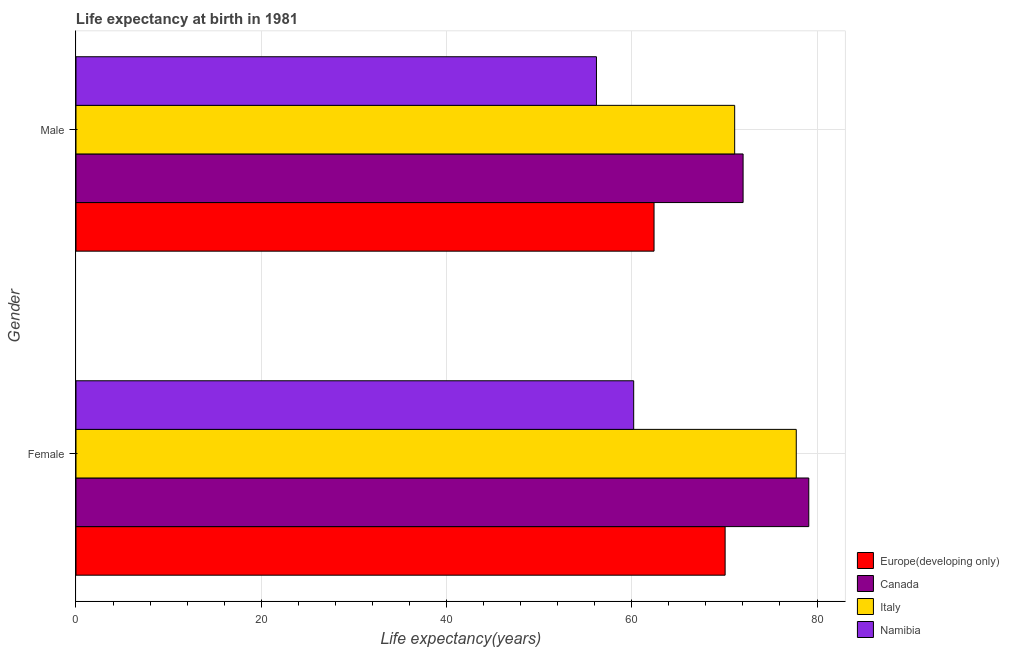How many different coloured bars are there?
Provide a short and direct response. 4. How many groups of bars are there?
Your response must be concise. 2. Are the number of bars per tick equal to the number of legend labels?
Offer a very short reply. Yes. Are the number of bars on each tick of the Y-axis equal?
Give a very brief answer. Yes. How many bars are there on the 2nd tick from the top?
Your answer should be very brief. 4. How many bars are there on the 1st tick from the bottom?
Your response must be concise. 4. What is the life expectancy(female) in Canada?
Your response must be concise. 79.11. Across all countries, what is the maximum life expectancy(female)?
Offer a very short reply. 79.11. Across all countries, what is the minimum life expectancy(male)?
Keep it short and to the point. 56.19. In which country was the life expectancy(female) minimum?
Your answer should be compact. Namibia. What is the total life expectancy(female) in the graph?
Give a very brief answer. 287.16. What is the difference between the life expectancy(female) in Namibia and that in Europe(developing only)?
Make the answer very short. -9.87. What is the difference between the life expectancy(female) in Canada and the life expectancy(male) in Europe(developing only)?
Offer a very short reply. 16.7. What is the average life expectancy(female) per country?
Make the answer very short. 71.79. What is the difference between the life expectancy(female) and life expectancy(male) in Italy?
Offer a very short reply. 6.65. In how many countries, is the life expectancy(male) greater than 12 years?
Give a very brief answer. 4. What is the ratio of the life expectancy(male) in Europe(developing only) to that in Namibia?
Provide a succinct answer. 1.11. In how many countries, is the life expectancy(male) greater than the average life expectancy(male) taken over all countries?
Your response must be concise. 2. What does the 3rd bar from the bottom in Female represents?
Your response must be concise. Italy. How many countries are there in the graph?
Make the answer very short. 4. Does the graph contain any zero values?
Offer a terse response. No. Does the graph contain grids?
Keep it short and to the point. Yes. Where does the legend appear in the graph?
Your answer should be compact. Bottom right. How many legend labels are there?
Ensure brevity in your answer.  4. How are the legend labels stacked?
Offer a terse response. Vertical. What is the title of the graph?
Offer a very short reply. Life expectancy at birth in 1981. Does "Luxembourg" appear as one of the legend labels in the graph?
Make the answer very short. No. What is the label or title of the X-axis?
Offer a terse response. Life expectancy(years). What is the Life expectancy(years) of Europe(developing only) in Female?
Offer a terse response. 70.08. What is the Life expectancy(years) in Canada in Female?
Make the answer very short. 79.11. What is the Life expectancy(years) of Italy in Female?
Give a very brief answer. 77.76. What is the Life expectancy(years) in Namibia in Female?
Provide a succinct answer. 60.21. What is the Life expectancy(years) of Europe(developing only) in Male?
Offer a terse response. 62.41. What is the Life expectancy(years) of Canada in Male?
Offer a very short reply. 72.02. What is the Life expectancy(years) in Italy in Male?
Offer a very short reply. 71.11. What is the Life expectancy(years) of Namibia in Male?
Keep it short and to the point. 56.19. Across all Gender, what is the maximum Life expectancy(years) in Europe(developing only)?
Provide a succinct answer. 70.08. Across all Gender, what is the maximum Life expectancy(years) of Canada?
Provide a succinct answer. 79.11. Across all Gender, what is the maximum Life expectancy(years) in Italy?
Provide a short and direct response. 77.76. Across all Gender, what is the maximum Life expectancy(years) in Namibia?
Give a very brief answer. 60.21. Across all Gender, what is the minimum Life expectancy(years) in Europe(developing only)?
Give a very brief answer. 62.41. Across all Gender, what is the minimum Life expectancy(years) of Canada?
Provide a succinct answer. 72.02. Across all Gender, what is the minimum Life expectancy(years) of Italy?
Offer a very short reply. 71.11. Across all Gender, what is the minimum Life expectancy(years) of Namibia?
Offer a very short reply. 56.19. What is the total Life expectancy(years) of Europe(developing only) in the graph?
Offer a terse response. 132.48. What is the total Life expectancy(years) in Canada in the graph?
Your answer should be very brief. 151.13. What is the total Life expectancy(years) of Italy in the graph?
Give a very brief answer. 148.87. What is the total Life expectancy(years) of Namibia in the graph?
Your response must be concise. 116.4. What is the difference between the Life expectancy(years) of Europe(developing only) in Female and that in Male?
Keep it short and to the point. 7.67. What is the difference between the Life expectancy(years) of Canada in Female and that in Male?
Your answer should be compact. 7.09. What is the difference between the Life expectancy(years) in Italy in Female and that in Male?
Provide a short and direct response. 6.65. What is the difference between the Life expectancy(years) in Namibia in Female and that in Male?
Ensure brevity in your answer.  4.02. What is the difference between the Life expectancy(years) in Europe(developing only) in Female and the Life expectancy(years) in Canada in Male?
Ensure brevity in your answer.  -1.94. What is the difference between the Life expectancy(years) of Europe(developing only) in Female and the Life expectancy(years) of Italy in Male?
Your answer should be very brief. -1.03. What is the difference between the Life expectancy(years) of Europe(developing only) in Female and the Life expectancy(years) of Namibia in Male?
Ensure brevity in your answer.  13.89. What is the difference between the Life expectancy(years) in Canada in Female and the Life expectancy(years) in Italy in Male?
Offer a very short reply. 8. What is the difference between the Life expectancy(years) in Canada in Female and the Life expectancy(years) in Namibia in Male?
Make the answer very short. 22.92. What is the difference between the Life expectancy(years) in Italy in Female and the Life expectancy(years) in Namibia in Male?
Ensure brevity in your answer.  21.57. What is the average Life expectancy(years) of Europe(developing only) per Gender?
Keep it short and to the point. 66.24. What is the average Life expectancy(years) of Canada per Gender?
Your answer should be very brief. 75.56. What is the average Life expectancy(years) of Italy per Gender?
Keep it short and to the point. 74.44. What is the average Life expectancy(years) of Namibia per Gender?
Provide a short and direct response. 58.2. What is the difference between the Life expectancy(years) in Europe(developing only) and Life expectancy(years) in Canada in Female?
Your answer should be compact. -9.03. What is the difference between the Life expectancy(years) of Europe(developing only) and Life expectancy(years) of Italy in Female?
Offer a terse response. -7.68. What is the difference between the Life expectancy(years) in Europe(developing only) and Life expectancy(years) in Namibia in Female?
Offer a very short reply. 9.87. What is the difference between the Life expectancy(years) of Canada and Life expectancy(years) of Italy in Female?
Offer a very short reply. 1.35. What is the difference between the Life expectancy(years) of Canada and Life expectancy(years) of Namibia in Female?
Keep it short and to the point. 18.9. What is the difference between the Life expectancy(years) in Italy and Life expectancy(years) in Namibia in Female?
Your answer should be compact. 17.55. What is the difference between the Life expectancy(years) in Europe(developing only) and Life expectancy(years) in Canada in Male?
Keep it short and to the point. -9.61. What is the difference between the Life expectancy(years) of Europe(developing only) and Life expectancy(years) of Italy in Male?
Provide a short and direct response. -8.7. What is the difference between the Life expectancy(years) in Europe(developing only) and Life expectancy(years) in Namibia in Male?
Offer a very short reply. 6.22. What is the difference between the Life expectancy(years) in Canada and Life expectancy(years) in Italy in Male?
Offer a terse response. 0.91. What is the difference between the Life expectancy(years) in Canada and Life expectancy(years) in Namibia in Male?
Your answer should be very brief. 15.83. What is the difference between the Life expectancy(years) in Italy and Life expectancy(years) in Namibia in Male?
Your answer should be very brief. 14.92. What is the ratio of the Life expectancy(years) in Europe(developing only) in Female to that in Male?
Your response must be concise. 1.12. What is the ratio of the Life expectancy(years) of Canada in Female to that in Male?
Offer a very short reply. 1.1. What is the ratio of the Life expectancy(years) of Italy in Female to that in Male?
Your answer should be compact. 1.09. What is the ratio of the Life expectancy(years) of Namibia in Female to that in Male?
Your answer should be compact. 1.07. What is the difference between the highest and the second highest Life expectancy(years) in Europe(developing only)?
Your answer should be compact. 7.67. What is the difference between the highest and the second highest Life expectancy(years) in Canada?
Your answer should be compact. 7.09. What is the difference between the highest and the second highest Life expectancy(years) in Italy?
Ensure brevity in your answer.  6.65. What is the difference between the highest and the second highest Life expectancy(years) in Namibia?
Offer a very short reply. 4.02. What is the difference between the highest and the lowest Life expectancy(years) in Europe(developing only)?
Make the answer very short. 7.67. What is the difference between the highest and the lowest Life expectancy(years) of Canada?
Give a very brief answer. 7.09. What is the difference between the highest and the lowest Life expectancy(years) of Italy?
Make the answer very short. 6.65. What is the difference between the highest and the lowest Life expectancy(years) of Namibia?
Provide a short and direct response. 4.02. 